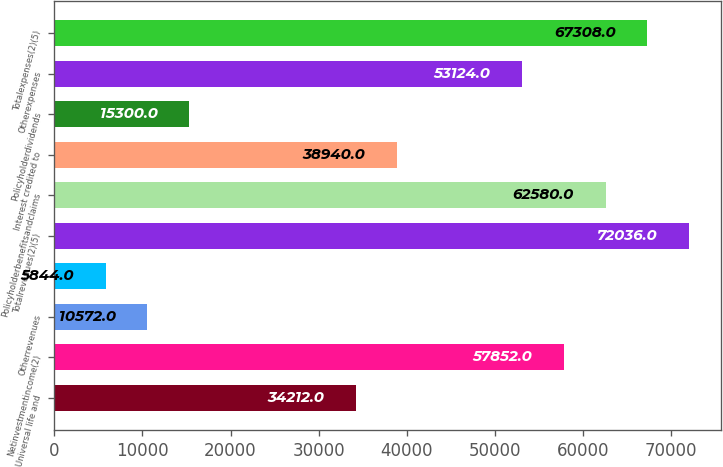Convert chart. <chart><loc_0><loc_0><loc_500><loc_500><bar_chart><fcel>Universal life and<fcel>Netinvestmentincome(2)<fcel>Otherrevenues<fcel>Unnamed: 3<fcel>Totalrevenues(2)(5)<fcel>Policyholderbenefitsandclaims<fcel>Interest credited to<fcel>Policyholderdividends<fcel>Otherexpenses<fcel>Totalexpenses(2)(5)<nl><fcel>34212<fcel>57852<fcel>10572<fcel>5844<fcel>72036<fcel>62580<fcel>38940<fcel>15300<fcel>53124<fcel>67308<nl></chart> 